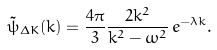Convert formula to latex. <formula><loc_0><loc_0><loc_500><loc_500>\tilde { \psi } _ { \Delta K } ( k ) = \frac { 4 \pi } { 3 } \frac { 2 k ^ { 2 } } { k ^ { 2 } - \omega ^ { 2 } } \, e ^ { - \lambda k } .</formula> 